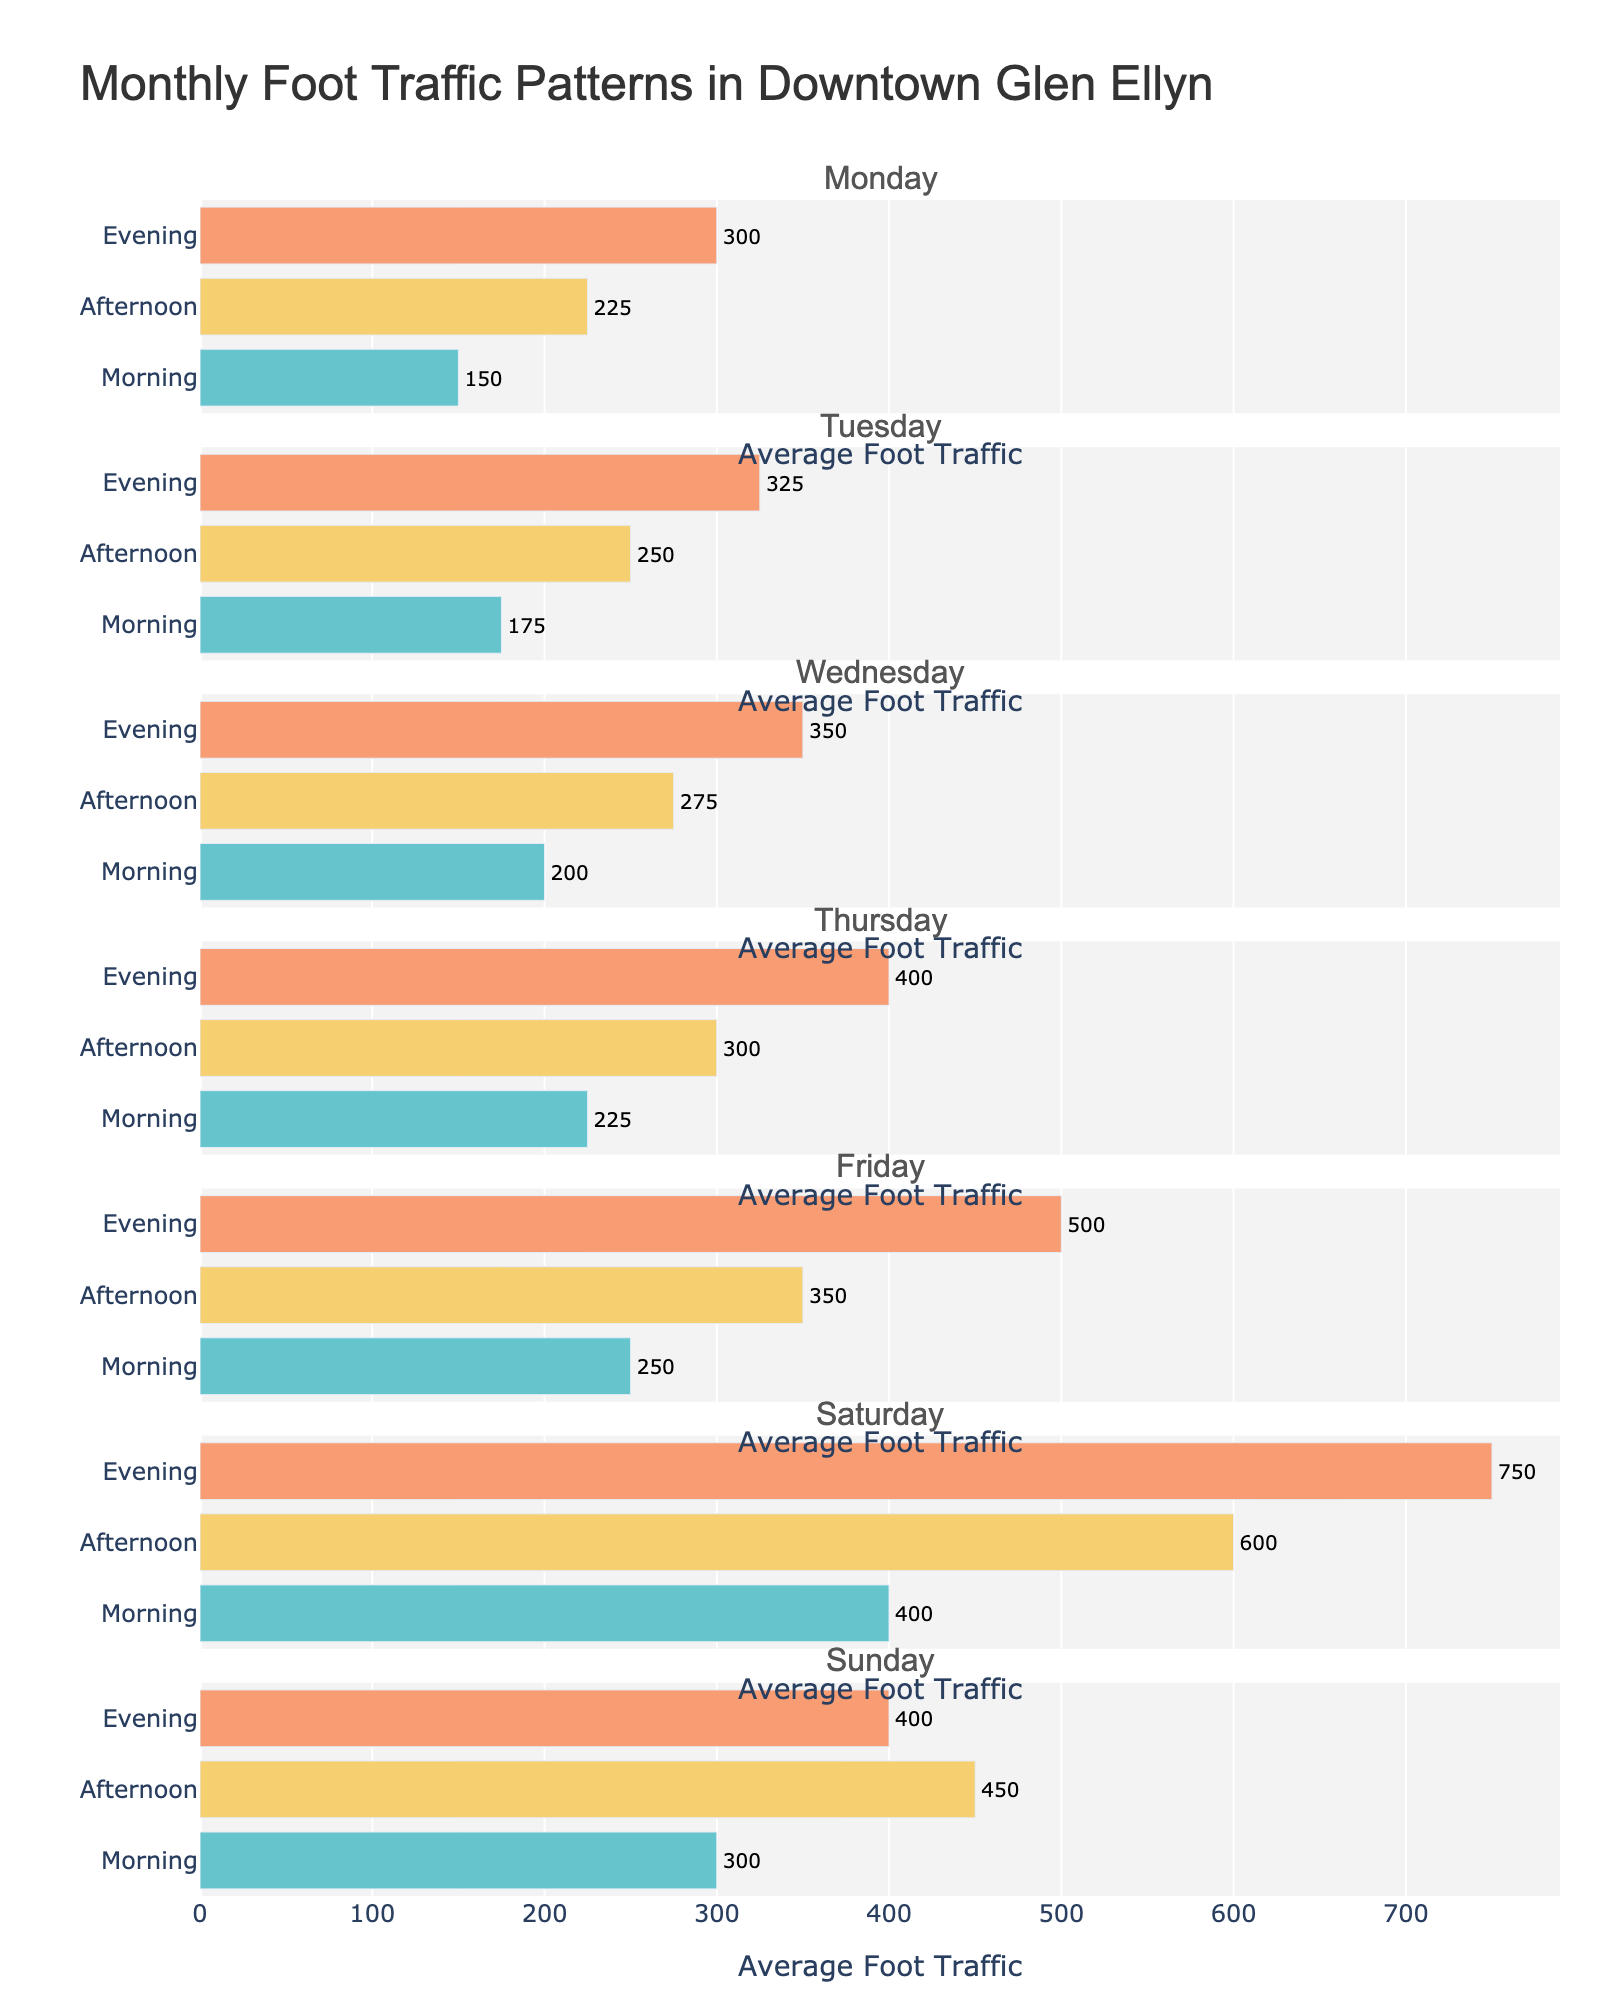What is the title of the figure? The title is displayed prominently at the top of the figure, reading "Monthly Foot Traffic Patterns in Downtown Glen Ellyn".
Answer: Monthly Foot Traffic Patterns in Downtown Glen Ellyn Which day and time slot has the highest average foot traffic? By examining the plot, it is clear that Saturday Evening has the tallest bar, indicating the highest average foot traffic.
Answer: Saturday Evening How does the average foot traffic on Wednesday Morning compare to Tuesday Morning? Find the bar that represents Wednesday Morning and note its value, then do the same for Tuesday Morning and compare. Wednesday Morning is 200, Tuesday Morning is 175, so Wednesday Morning is higher.
Answer: Wednesday Morning is higher On which day does the Afternoon time slot have the greatest average foot traffic? By scanning the Afternoon bars for each day, the bar for Saturday Afternoon is the tallest, indicating the greatest average foot traffic for that time slot.
Answer: Saturday What is the total average foot traffic for Sunday? Sum the heights of the bars for Sunday Morning, Sunday Afternoon, and Sunday Evening. The values are 300, 450, and 400 respectively, so the total is 300 + 450 + 400 = 1150.
Answer: 1150 How does the foot traffic pattern change from Friday to Saturday? Look at the sequence of bars for Friday and then for Saturday. Friday shows a steady increase from Morning (250) to Afternoon (350) to Evening (500), while Saturday shows a much sharper increase from Morning (400) to Afternoon (600) to Evening (750).
Answer: There is a sharper increase on Saturday What’s the difference in foot traffic between the busiest and least busy weekday time slots? Identify the busiest and least busy weekday time slots. The busiest weekday slot is Friday Evening (500) and the least busy weekday slot is Monday Morning (150). The difference is 500 - 150 = 350.
Answer: 350 Which time of day generally has the lowest average foot traffic throughout the week? Observe the bars across all days for Morning, Afternoon, and Evening and identify the time with the overall shortest bars. Morning generally has the lowest average foot traffic.
Answer: Morning What is the average foot traffic for all Morning time slots combined? Sum the Morning foot traffic values across all days and divide by the number of days (7). The total foot traffic is 150 + 175 + 200 + 225 + 250 + 400 + 300 = 1700, and 1700 / 7 ≈ 242.86.
Answer: 242.86 Which weekday has the most significant foot traffic difference between Morning and Evening? Calculate the difference for each weekday between the Evening and Morning slots, then compare these differences. Monday's difference is 150, Tuesday's is 150, Wednesday's is 150, Thursday's is 175, and Friday's is 250. Thus, Friday has the most significant difference.
Answer: Friday 